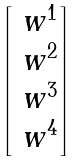<formula> <loc_0><loc_0><loc_500><loc_500>\begin{bmatrix} \ w ^ { 1 } \\ \ w ^ { 2 } \\ \ w ^ { 3 } \\ \ w ^ { 4 } \end{bmatrix}</formula> 